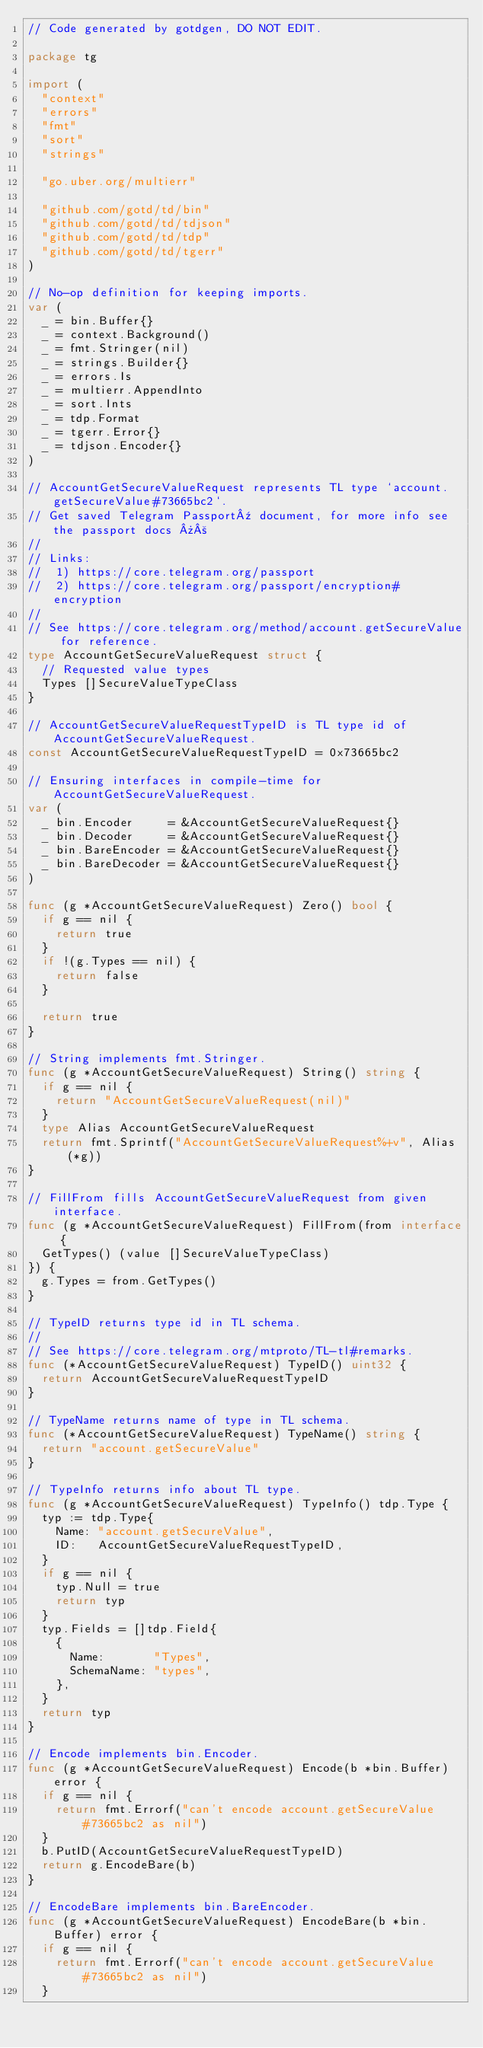<code> <loc_0><loc_0><loc_500><loc_500><_Go_>// Code generated by gotdgen, DO NOT EDIT.

package tg

import (
	"context"
	"errors"
	"fmt"
	"sort"
	"strings"

	"go.uber.org/multierr"

	"github.com/gotd/td/bin"
	"github.com/gotd/td/tdjson"
	"github.com/gotd/td/tdp"
	"github.com/gotd/td/tgerr"
)

// No-op definition for keeping imports.
var (
	_ = bin.Buffer{}
	_ = context.Background()
	_ = fmt.Stringer(nil)
	_ = strings.Builder{}
	_ = errors.Is
	_ = multierr.AppendInto
	_ = sort.Ints
	_ = tdp.Format
	_ = tgerr.Error{}
	_ = tdjson.Encoder{}
)

// AccountGetSecureValueRequest represents TL type `account.getSecureValue#73665bc2`.
// Get saved Telegram Passport¹ document, for more info see the passport docs »²
//
// Links:
//  1) https://core.telegram.org/passport
//  2) https://core.telegram.org/passport/encryption#encryption
//
// See https://core.telegram.org/method/account.getSecureValue for reference.
type AccountGetSecureValueRequest struct {
	// Requested value types
	Types []SecureValueTypeClass
}

// AccountGetSecureValueRequestTypeID is TL type id of AccountGetSecureValueRequest.
const AccountGetSecureValueRequestTypeID = 0x73665bc2

// Ensuring interfaces in compile-time for AccountGetSecureValueRequest.
var (
	_ bin.Encoder     = &AccountGetSecureValueRequest{}
	_ bin.Decoder     = &AccountGetSecureValueRequest{}
	_ bin.BareEncoder = &AccountGetSecureValueRequest{}
	_ bin.BareDecoder = &AccountGetSecureValueRequest{}
)

func (g *AccountGetSecureValueRequest) Zero() bool {
	if g == nil {
		return true
	}
	if !(g.Types == nil) {
		return false
	}

	return true
}

// String implements fmt.Stringer.
func (g *AccountGetSecureValueRequest) String() string {
	if g == nil {
		return "AccountGetSecureValueRequest(nil)"
	}
	type Alias AccountGetSecureValueRequest
	return fmt.Sprintf("AccountGetSecureValueRequest%+v", Alias(*g))
}

// FillFrom fills AccountGetSecureValueRequest from given interface.
func (g *AccountGetSecureValueRequest) FillFrom(from interface {
	GetTypes() (value []SecureValueTypeClass)
}) {
	g.Types = from.GetTypes()
}

// TypeID returns type id in TL schema.
//
// See https://core.telegram.org/mtproto/TL-tl#remarks.
func (*AccountGetSecureValueRequest) TypeID() uint32 {
	return AccountGetSecureValueRequestTypeID
}

// TypeName returns name of type in TL schema.
func (*AccountGetSecureValueRequest) TypeName() string {
	return "account.getSecureValue"
}

// TypeInfo returns info about TL type.
func (g *AccountGetSecureValueRequest) TypeInfo() tdp.Type {
	typ := tdp.Type{
		Name: "account.getSecureValue",
		ID:   AccountGetSecureValueRequestTypeID,
	}
	if g == nil {
		typ.Null = true
		return typ
	}
	typ.Fields = []tdp.Field{
		{
			Name:       "Types",
			SchemaName: "types",
		},
	}
	return typ
}

// Encode implements bin.Encoder.
func (g *AccountGetSecureValueRequest) Encode(b *bin.Buffer) error {
	if g == nil {
		return fmt.Errorf("can't encode account.getSecureValue#73665bc2 as nil")
	}
	b.PutID(AccountGetSecureValueRequestTypeID)
	return g.EncodeBare(b)
}

// EncodeBare implements bin.BareEncoder.
func (g *AccountGetSecureValueRequest) EncodeBare(b *bin.Buffer) error {
	if g == nil {
		return fmt.Errorf("can't encode account.getSecureValue#73665bc2 as nil")
	}</code> 